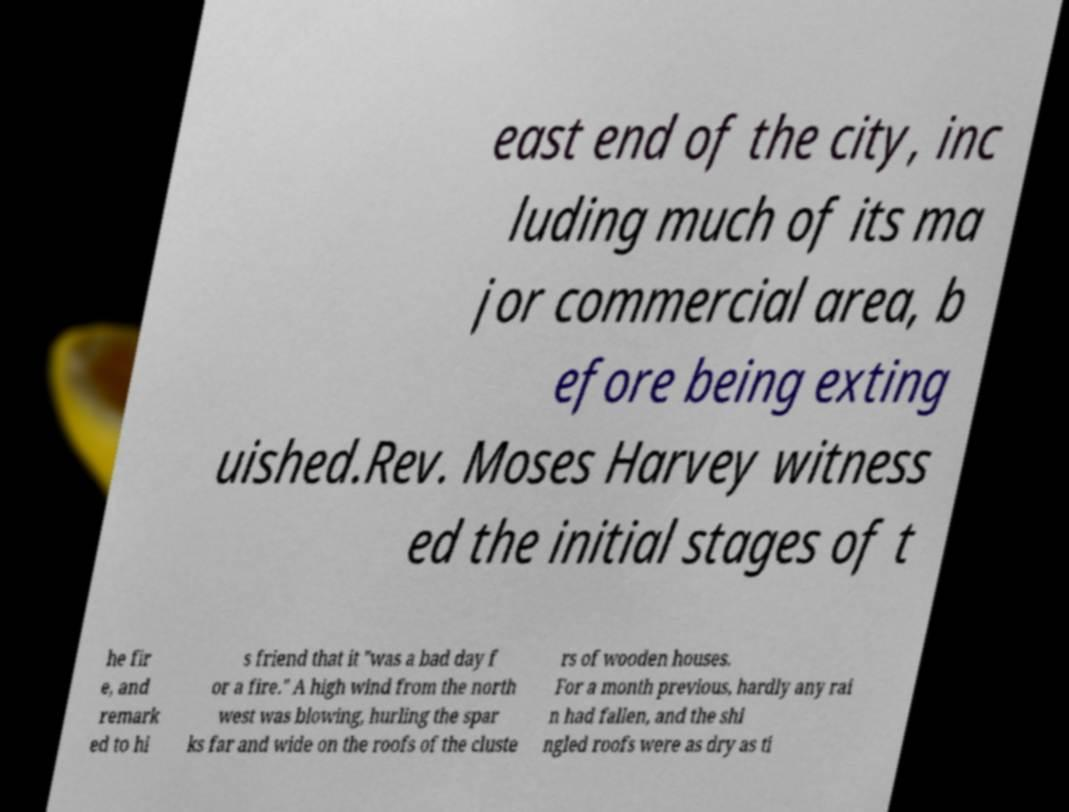For documentation purposes, I need the text within this image transcribed. Could you provide that? east end of the city, inc luding much of its ma jor commercial area, b efore being exting uished.Rev. Moses Harvey witness ed the initial stages of t he fir e, and remark ed to hi s friend that it "was a bad day f or a fire." A high wind from the north west was blowing, hurling the spar ks far and wide on the roofs of the cluste rs of wooden houses. For a month previous, hardly any rai n had fallen, and the shi ngled roofs were as dry as ti 